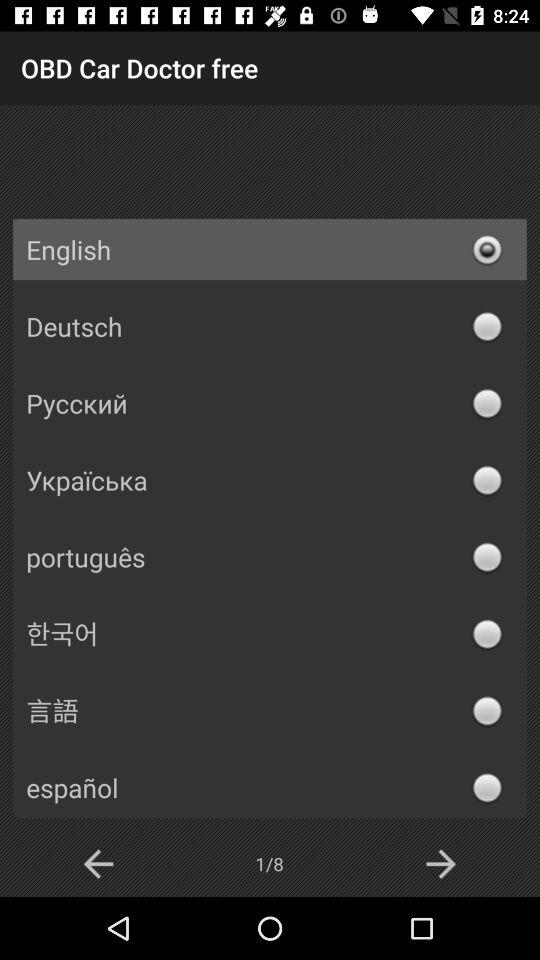How many languages are available in the language selection menu?
Answer the question using a single word or phrase. 8 